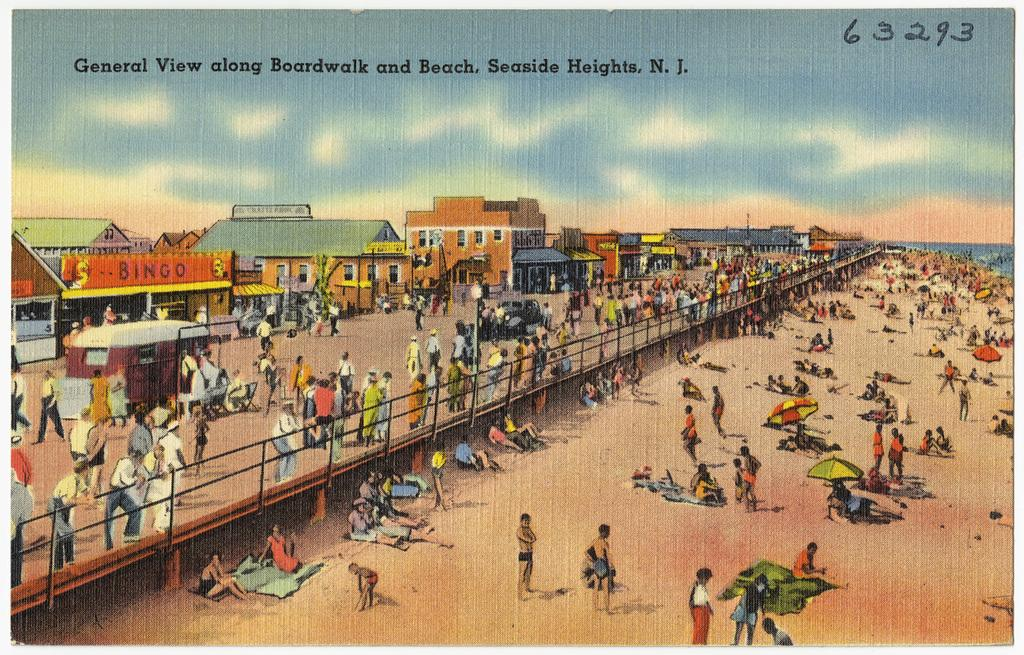<image>
Share a concise interpretation of the image provided. A postcard with a view of the beach is captioned "general view along Boardwalk and Beach, Seaside Heights, N.J." 